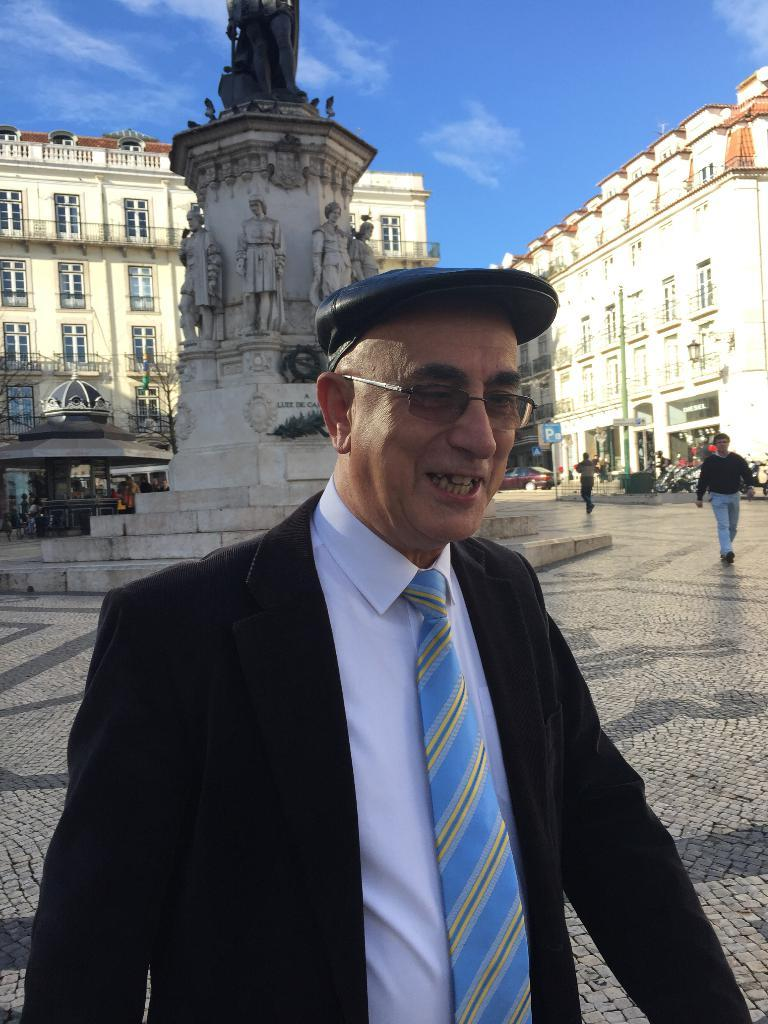What is happening on the road in the image? There is a crowd on the road in the image. What can be seen in the background of the image? There are buildings, shops, boards, and statues in the background of the image. What is visible at the top of the image? The sky is visible at the top of the image. Where was the image taken? The image was taken on the road. How many dogs are performing an action in the image? There are no dogs or actions being performed by dogs in the image. 